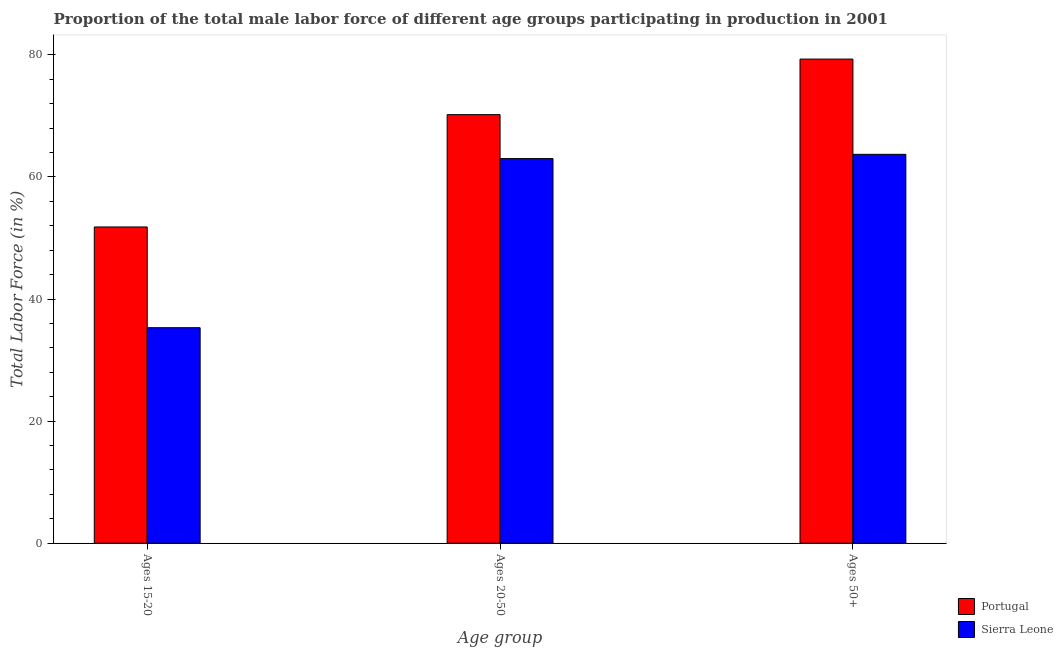Are the number of bars on each tick of the X-axis equal?
Your answer should be very brief. Yes. How many bars are there on the 1st tick from the right?
Ensure brevity in your answer.  2. What is the label of the 2nd group of bars from the left?
Your response must be concise. Ages 20-50. What is the percentage of male labor force within the age group 15-20 in Portugal?
Your answer should be compact. 51.8. Across all countries, what is the maximum percentage of male labor force within the age group 20-50?
Give a very brief answer. 70.2. Across all countries, what is the minimum percentage of male labor force within the age group 15-20?
Make the answer very short. 35.3. In which country was the percentage of male labor force within the age group 15-20 maximum?
Provide a short and direct response. Portugal. In which country was the percentage of male labor force within the age group 20-50 minimum?
Offer a very short reply. Sierra Leone. What is the total percentage of male labor force above age 50 in the graph?
Ensure brevity in your answer.  143. What is the difference between the percentage of male labor force within the age group 20-50 in Portugal and that in Sierra Leone?
Keep it short and to the point. 7.2. What is the difference between the percentage of male labor force within the age group 15-20 in Portugal and the percentage of male labor force above age 50 in Sierra Leone?
Offer a very short reply. -11.9. What is the average percentage of male labor force within the age group 20-50 per country?
Make the answer very short. 66.6. What is the difference between the percentage of male labor force above age 50 and percentage of male labor force within the age group 15-20 in Portugal?
Your answer should be very brief. 27.5. What is the ratio of the percentage of male labor force within the age group 20-50 in Portugal to that in Sierra Leone?
Provide a short and direct response. 1.11. What is the difference between the highest and the second highest percentage of male labor force above age 50?
Give a very brief answer. 15.6. What is the difference between the highest and the lowest percentage of male labor force within the age group 20-50?
Ensure brevity in your answer.  7.2. What does the 2nd bar from the left in Ages 15-20 represents?
Offer a very short reply. Sierra Leone. What does the 1st bar from the right in Ages 50+ represents?
Make the answer very short. Sierra Leone. What is the difference between two consecutive major ticks on the Y-axis?
Provide a succinct answer. 20. Does the graph contain any zero values?
Offer a very short reply. No. Does the graph contain grids?
Offer a terse response. No. What is the title of the graph?
Make the answer very short. Proportion of the total male labor force of different age groups participating in production in 2001. Does "Malaysia" appear as one of the legend labels in the graph?
Your response must be concise. No. What is the label or title of the X-axis?
Give a very brief answer. Age group. What is the label or title of the Y-axis?
Provide a short and direct response. Total Labor Force (in %). What is the Total Labor Force (in %) in Portugal in Ages 15-20?
Keep it short and to the point. 51.8. What is the Total Labor Force (in %) in Sierra Leone in Ages 15-20?
Ensure brevity in your answer.  35.3. What is the Total Labor Force (in %) in Portugal in Ages 20-50?
Give a very brief answer. 70.2. What is the Total Labor Force (in %) of Portugal in Ages 50+?
Offer a very short reply. 79.3. What is the Total Labor Force (in %) in Sierra Leone in Ages 50+?
Offer a terse response. 63.7. Across all Age group, what is the maximum Total Labor Force (in %) of Portugal?
Keep it short and to the point. 79.3. Across all Age group, what is the maximum Total Labor Force (in %) of Sierra Leone?
Ensure brevity in your answer.  63.7. Across all Age group, what is the minimum Total Labor Force (in %) of Portugal?
Provide a short and direct response. 51.8. Across all Age group, what is the minimum Total Labor Force (in %) in Sierra Leone?
Your answer should be very brief. 35.3. What is the total Total Labor Force (in %) of Portugal in the graph?
Give a very brief answer. 201.3. What is the total Total Labor Force (in %) of Sierra Leone in the graph?
Your answer should be compact. 162. What is the difference between the Total Labor Force (in %) in Portugal in Ages 15-20 and that in Ages 20-50?
Offer a terse response. -18.4. What is the difference between the Total Labor Force (in %) in Sierra Leone in Ages 15-20 and that in Ages 20-50?
Give a very brief answer. -27.7. What is the difference between the Total Labor Force (in %) of Portugal in Ages 15-20 and that in Ages 50+?
Give a very brief answer. -27.5. What is the difference between the Total Labor Force (in %) of Sierra Leone in Ages 15-20 and that in Ages 50+?
Provide a succinct answer. -28.4. What is the difference between the Total Labor Force (in %) in Portugal in Ages 20-50 and that in Ages 50+?
Provide a succinct answer. -9.1. What is the average Total Labor Force (in %) in Portugal per Age group?
Keep it short and to the point. 67.1. What is the difference between the Total Labor Force (in %) of Portugal and Total Labor Force (in %) of Sierra Leone in Ages 50+?
Make the answer very short. 15.6. What is the ratio of the Total Labor Force (in %) in Portugal in Ages 15-20 to that in Ages 20-50?
Your answer should be compact. 0.74. What is the ratio of the Total Labor Force (in %) in Sierra Leone in Ages 15-20 to that in Ages 20-50?
Your answer should be compact. 0.56. What is the ratio of the Total Labor Force (in %) of Portugal in Ages 15-20 to that in Ages 50+?
Make the answer very short. 0.65. What is the ratio of the Total Labor Force (in %) of Sierra Leone in Ages 15-20 to that in Ages 50+?
Provide a short and direct response. 0.55. What is the ratio of the Total Labor Force (in %) of Portugal in Ages 20-50 to that in Ages 50+?
Your answer should be very brief. 0.89. What is the difference between the highest and the lowest Total Labor Force (in %) of Sierra Leone?
Keep it short and to the point. 28.4. 